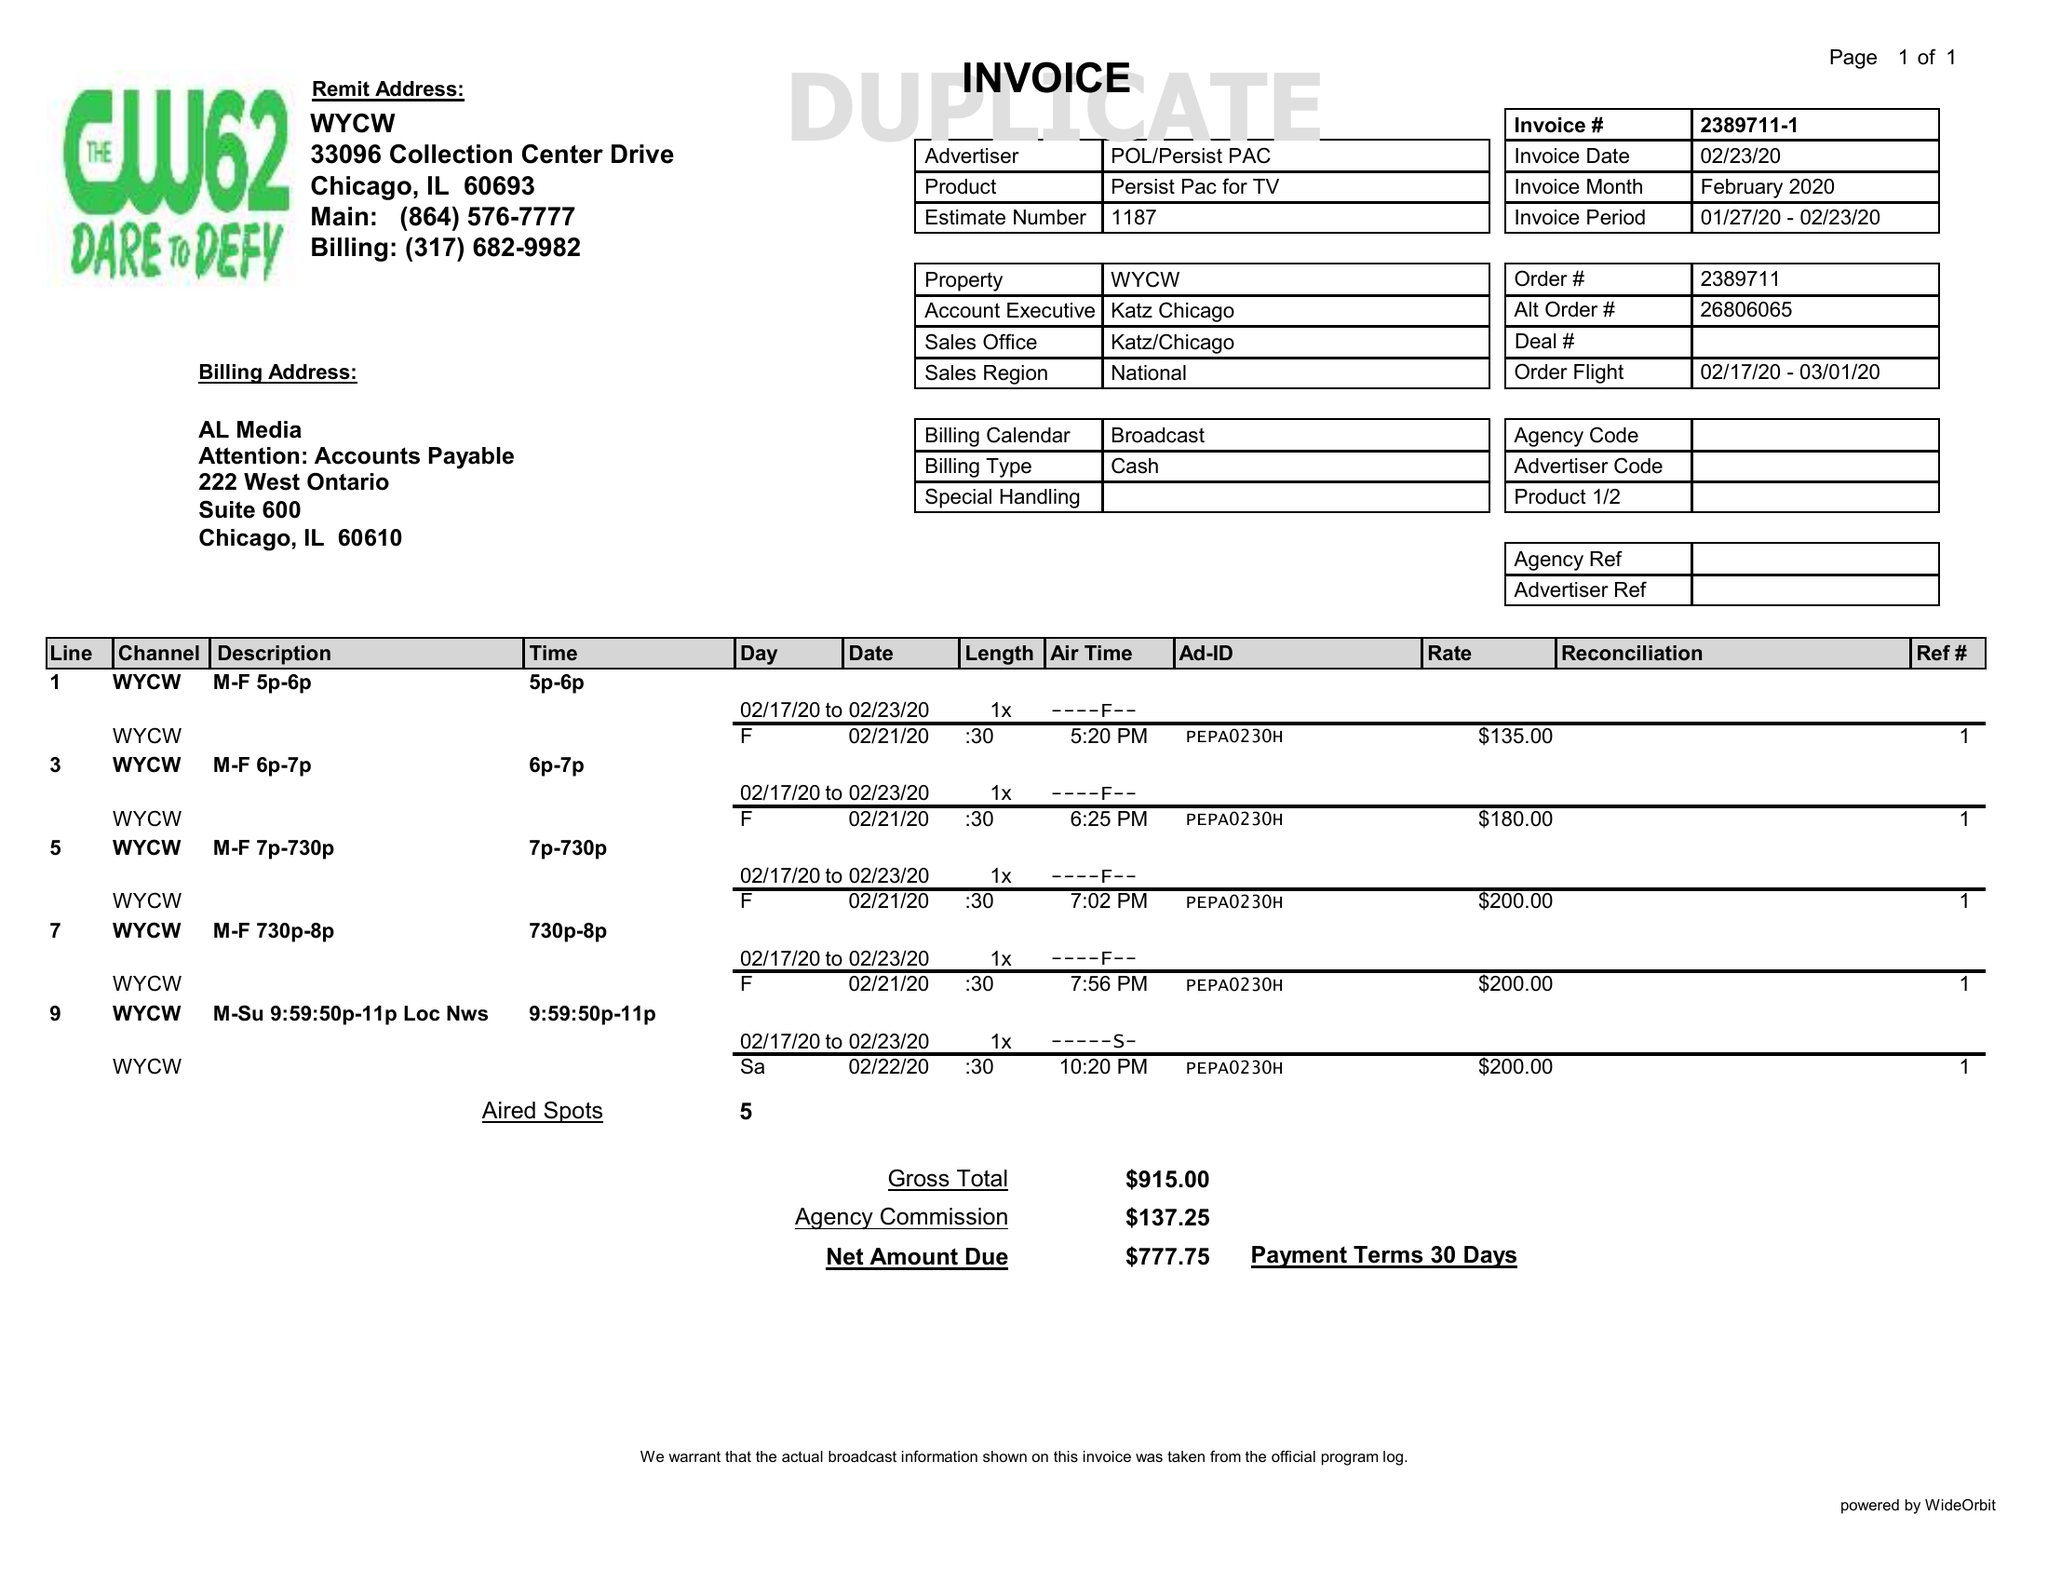What is the value for the advertiser?
Answer the question using a single word or phrase. POL/PERSISTPAC 